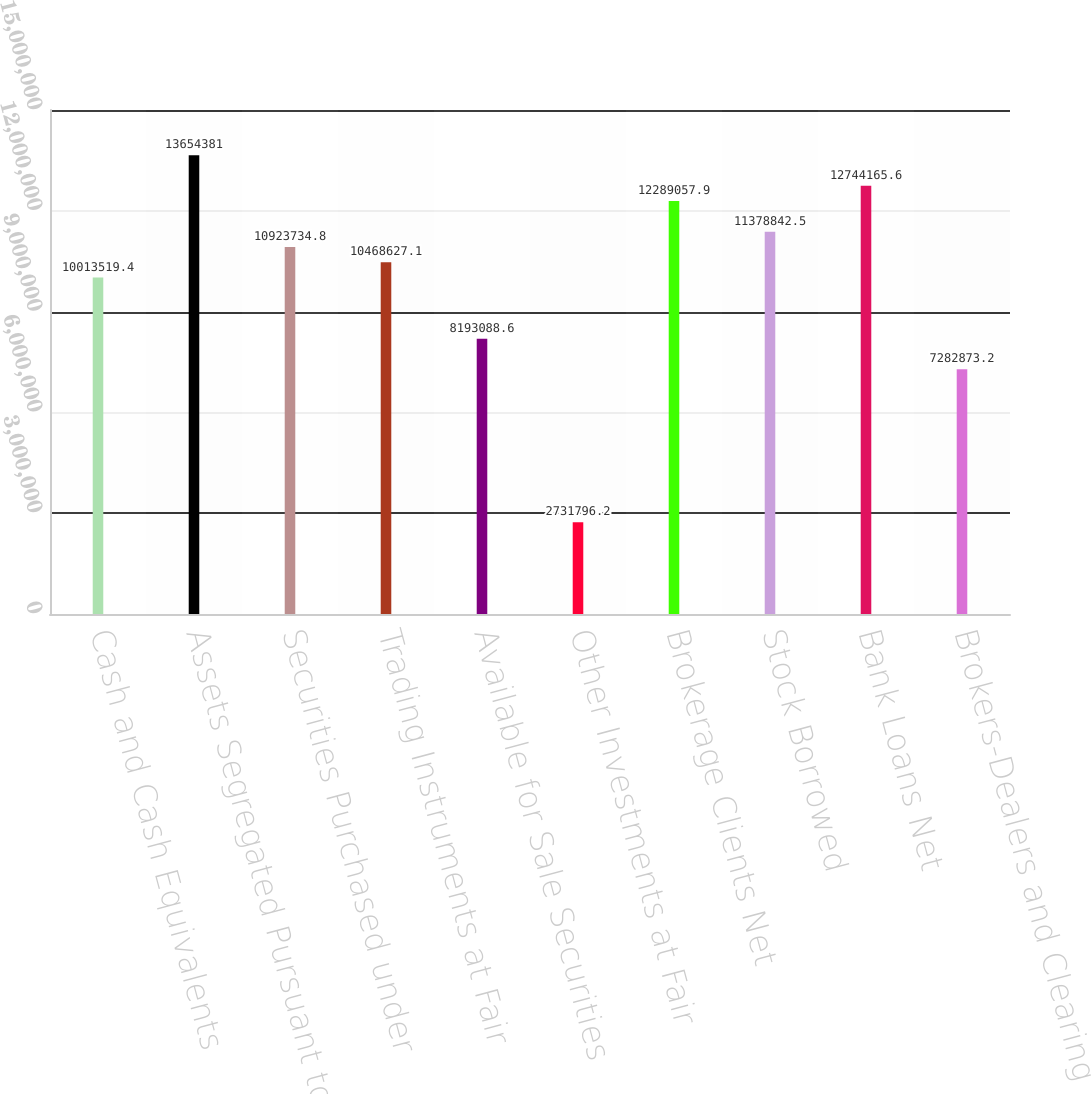Convert chart. <chart><loc_0><loc_0><loc_500><loc_500><bar_chart><fcel>Cash and Cash Equivalents<fcel>Assets Segregated Pursuant to<fcel>Securities Purchased under<fcel>Trading Instruments at Fair<fcel>Available for Sale Securities<fcel>Other Investments at Fair<fcel>Brokerage Clients Net<fcel>Stock Borrowed<fcel>Bank Loans Net<fcel>Brokers-Dealers and Clearing<nl><fcel>1.00135e+07<fcel>1.36544e+07<fcel>1.09237e+07<fcel>1.04686e+07<fcel>8.19309e+06<fcel>2.7318e+06<fcel>1.22891e+07<fcel>1.13788e+07<fcel>1.27442e+07<fcel>7.28287e+06<nl></chart> 